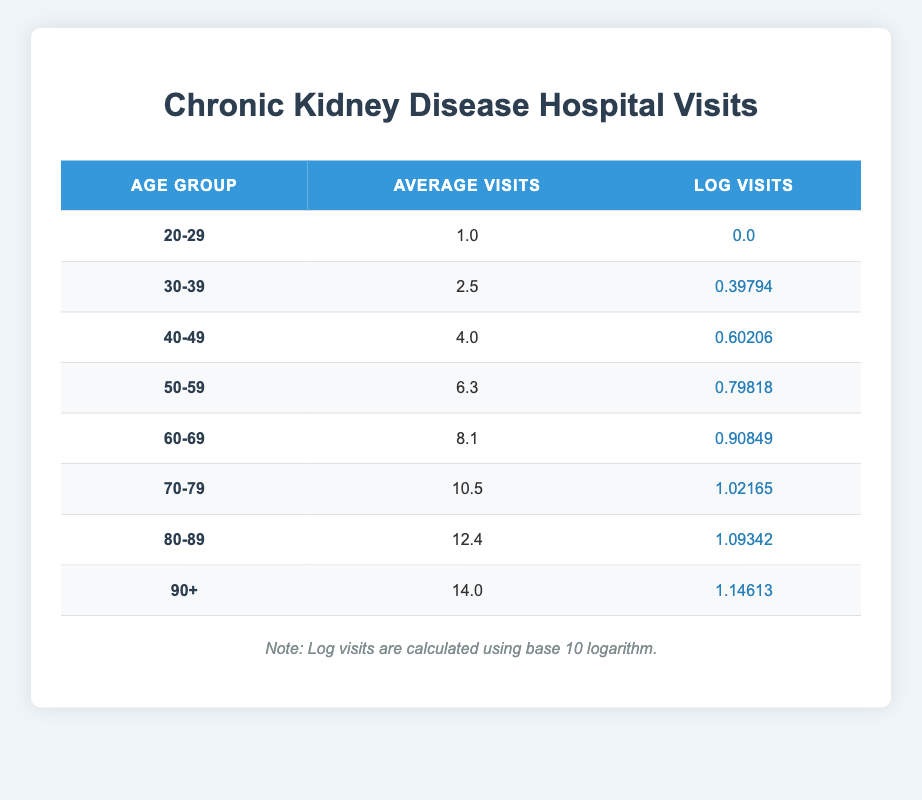What is the average number of hospital visits for patients aged 30-39? The average number of hospital visits for the age group 30-39 is provided directly in the table under "Average Visits" for that group, which states 2.5.
Answer: 2.5 Which age group has the highest average number of hospital visits? From the table, the age group 90+ has the highest average visits listed as 14.0.
Answer: 90+ Is the average number of visits for patients aged 60-69 greater than 8? Looking at the average visits for the age group 60-69, the table shows 8.1, which is greater than 8, confirming the statement as true.
Answer: True What is the difference in average visits between the age groups 50-59 and 70-79? For age group 50-59, the average visits are 6.3, and for 70-79, they are 10.5. The difference is calculated by subtracting 6.3 from 10.5, which equals 4.2.
Answer: 4.2 How many age groups have average hospital visits greater than or equal to 10? By analyzing the data, the groups 70-79 (10.5), 80-89 (12.4), and 90+ (14.0) all have average visits greater than or equal to 10. This makes a total of 3 age groups.
Answer: 3 What is the total average number of visits for the age groups between 60-69 and 90+? The average visits for the age group 60-69 is 8.1, and for the 90+ group, it is 14.0. Adding these two values together, 8.1 + 14.0 = 22.1 gives the total.
Answer: 22.1 Which is greater: the average visits for the age group 80-89 or for 30-39? The average visits for age group 80-89 is 12.4 while for 30-39 it is 2.5. Comparing these two values shows that 12.4 is greater than 2.5. Therefore, 80-89 is greater.
Answer: 80-89 What is the average of the average visits across all age groups? To find the average of all age groups, we sum the average visits for each group and divide by the number of groups. The sum is 1.0 + 2.5 + 4.0 + 6.3 + 8.1 + 10.5 + 12.4 + 14.0 = 58.8, and there are 8 groups, so the average is 58.8 / 8 = 7.35.
Answer: 7.35 